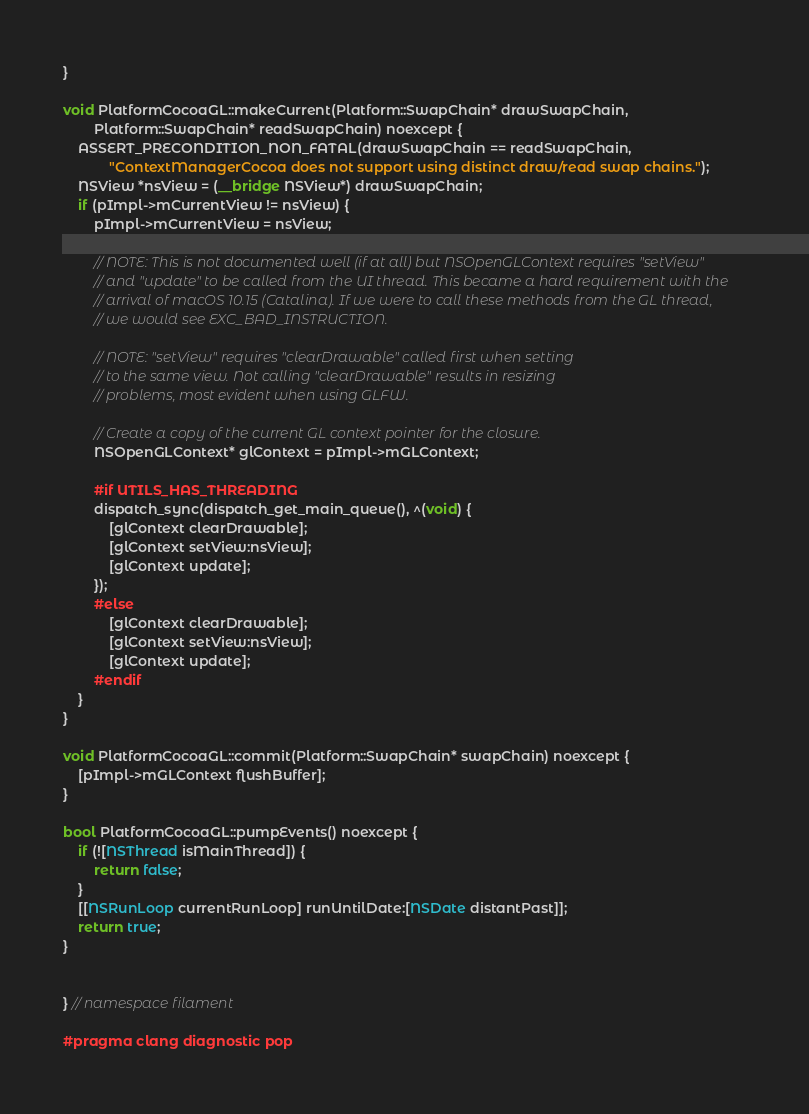Convert code to text. <code><loc_0><loc_0><loc_500><loc_500><_ObjectiveC_>}

void PlatformCocoaGL::makeCurrent(Platform::SwapChain* drawSwapChain,
        Platform::SwapChain* readSwapChain) noexcept {
    ASSERT_PRECONDITION_NON_FATAL(drawSwapChain == readSwapChain,
            "ContextManagerCocoa does not support using distinct draw/read swap chains.");
    NSView *nsView = (__bridge NSView*) drawSwapChain;
    if (pImpl->mCurrentView != nsView) {
        pImpl->mCurrentView = nsView;

        // NOTE: This is not documented well (if at all) but NSOpenGLContext requires "setView"
        // and "update" to be called from the UI thread. This became a hard requirement with the
        // arrival of macOS 10.15 (Catalina). If we were to call these methods from the GL thread,
        // we would see EXC_BAD_INSTRUCTION.

        // NOTE: "setView" requires "clearDrawable" called first when setting
        // to the same view. Not calling "clearDrawable" results in resizing
        // problems, most evident when using GLFW.

        // Create a copy of the current GL context pointer for the closure.
        NSOpenGLContext* glContext = pImpl->mGLContext;

        #if UTILS_HAS_THREADING
        dispatch_sync(dispatch_get_main_queue(), ^(void) {
            [glContext clearDrawable];
            [glContext setView:nsView];
            [glContext update];
        });
        #else
            [glContext clearDrawable];
            [glContext setView:nsView];
            [glContext update];
        #endif
    }
}

void PlatformCocoaGL::commit(Platform::SwapChain* swapChain) noexcept {
    [pImpl->mGLContext flushBuffer];
}

bool PlatformCocoaGL::pumpEvents() noexcept {
    if (![NSThread isMainThread]) {
        return false;
    }
    [[NSRunLoop currentRunLoop] runUntilDate:[NSDate distantPast]];
    return true;
}


} // namespace filament

#pragma clang diagnostic pop
</code> 